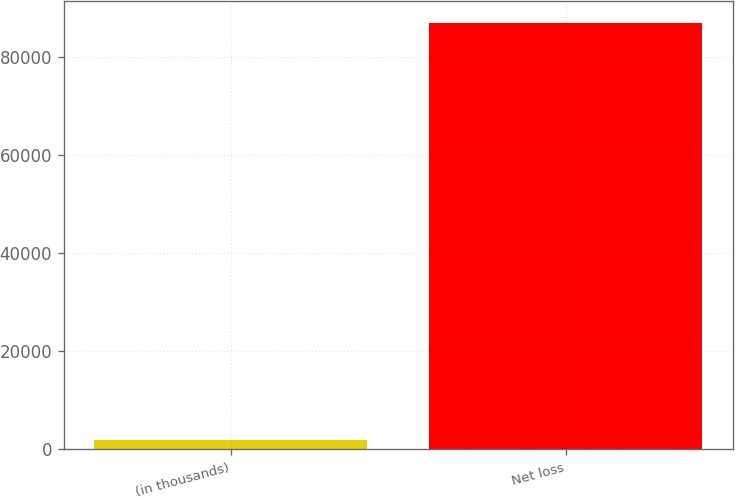Convert chart. <chart><loc_0><loc_0><loc_500><loc_500><bar_chart><fcel>(in thousands)<fcel>Net loss<nl><fcel>2011<fcel>87035<nl></chart> 